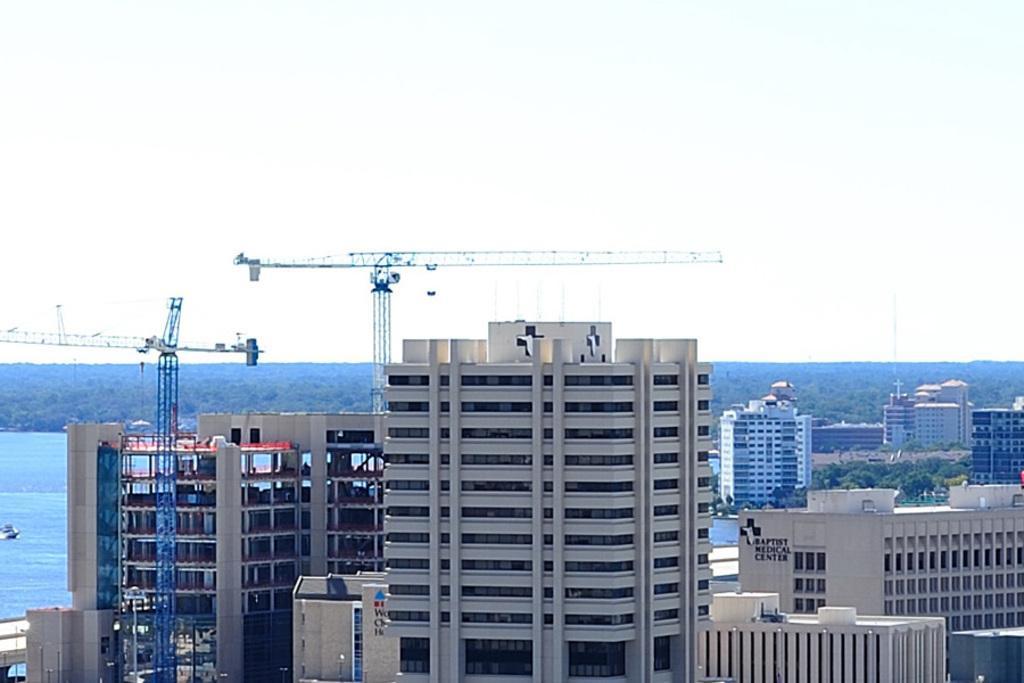Could you give a brief overview of what you see in this image? This is an outside view. Here I can see some buildings and two cranes. On the left side there is a sea and I can see a boat. In the background there are some trees. On the top of the image I can see the sky. 